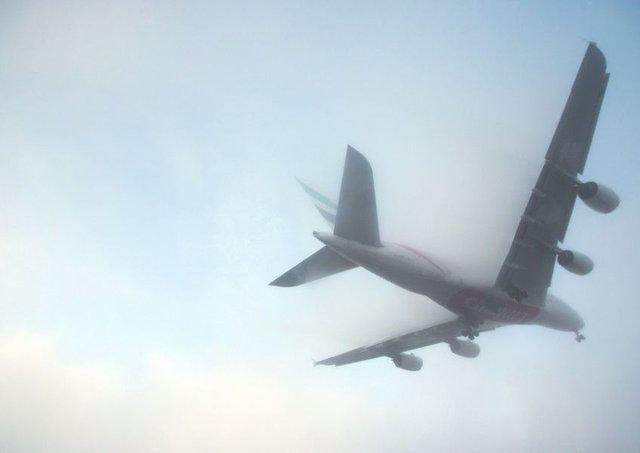What kind of aeroplane seems to be in the photo? The aeroplane appears to be a commercial passenger jet, likely a twin-engine model given the two large jet engines under each wing. The configuration suggests it is designed for medium to long-haul flights. 